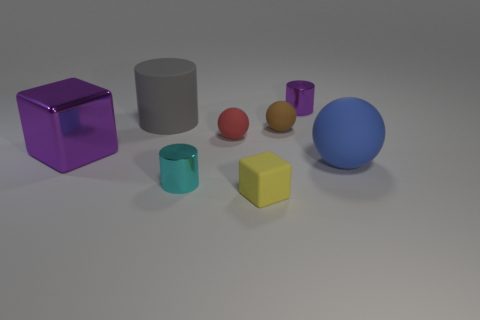There is a purple metallic thing on the left side of the small block; what is its size?
Give a very brief answer. Large. There is a ball that is on the right side of the yellow block and on the left side of the small purple cylinder; what is its color?
Offer a terse response. Brown. Is the size of the blue sphere that is on the right side of the purple metallic block the same as the large shiny block?
Provide a short and direct response. Yes. There is a big matte object that is on the left side of the big matte ball; is there a large blue rubber object to the left of it?
Ensure brevity in your answer.  No. What is the small yellow block made of?
Your response must be concise. Rubber. Are there any small balls behind the tiny brown matte sphere?
Your answer should be compact. No. What is the size of the blue object that is the same shape as the tiny red thing?
Keep it short and to the point. Large. Are there an equal number of big purple things to the right of the brown ball and brown balls on the left side of the cyan object?
Offer a very short reply. Yes. What number of big metal objects are there?
Ensure brevity in your answer.  1. Is the number of cyan things that are on the right side of the small cyan shiny object greater than the number of yellow matte objects?
Give a very brief answer. No. 